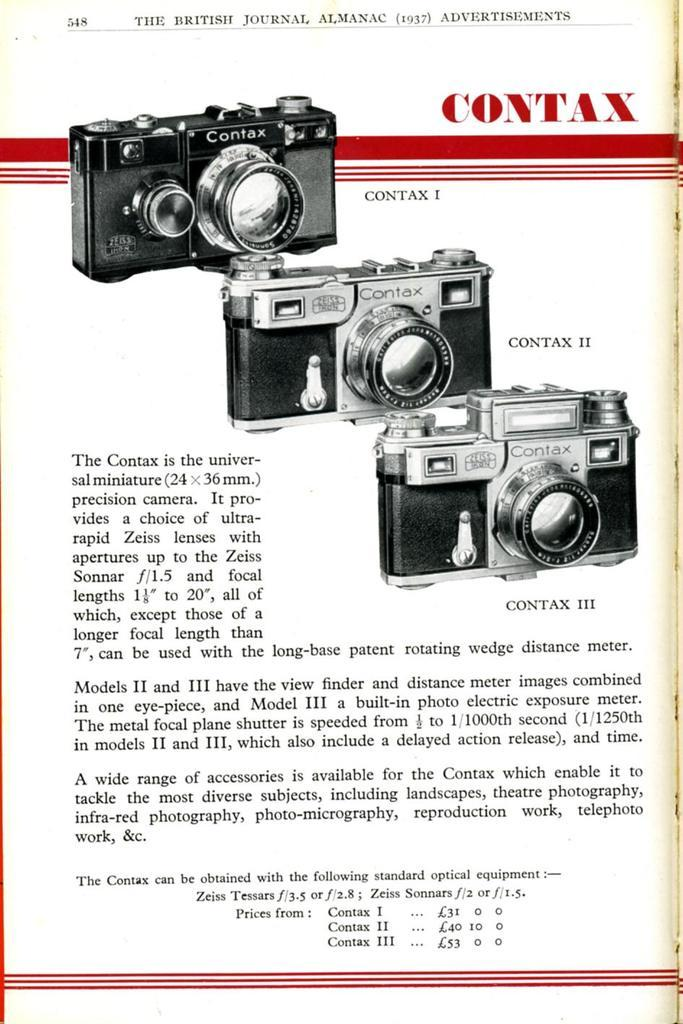<image>
Write a terse but informative summary of the picture. An older flyer for a Contax I, II and III camera. 